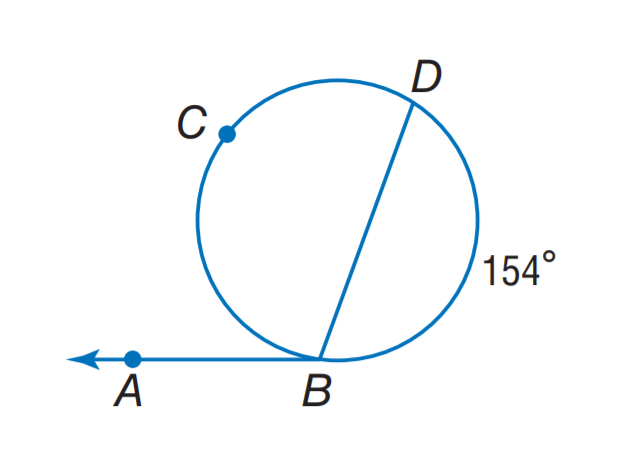Answer the mathemtical geometry problem and directly provide the correct option letter.
Question: Find m \angle A B D.
Choices: A: 97 B: 103 C: 126 D: 154 B 